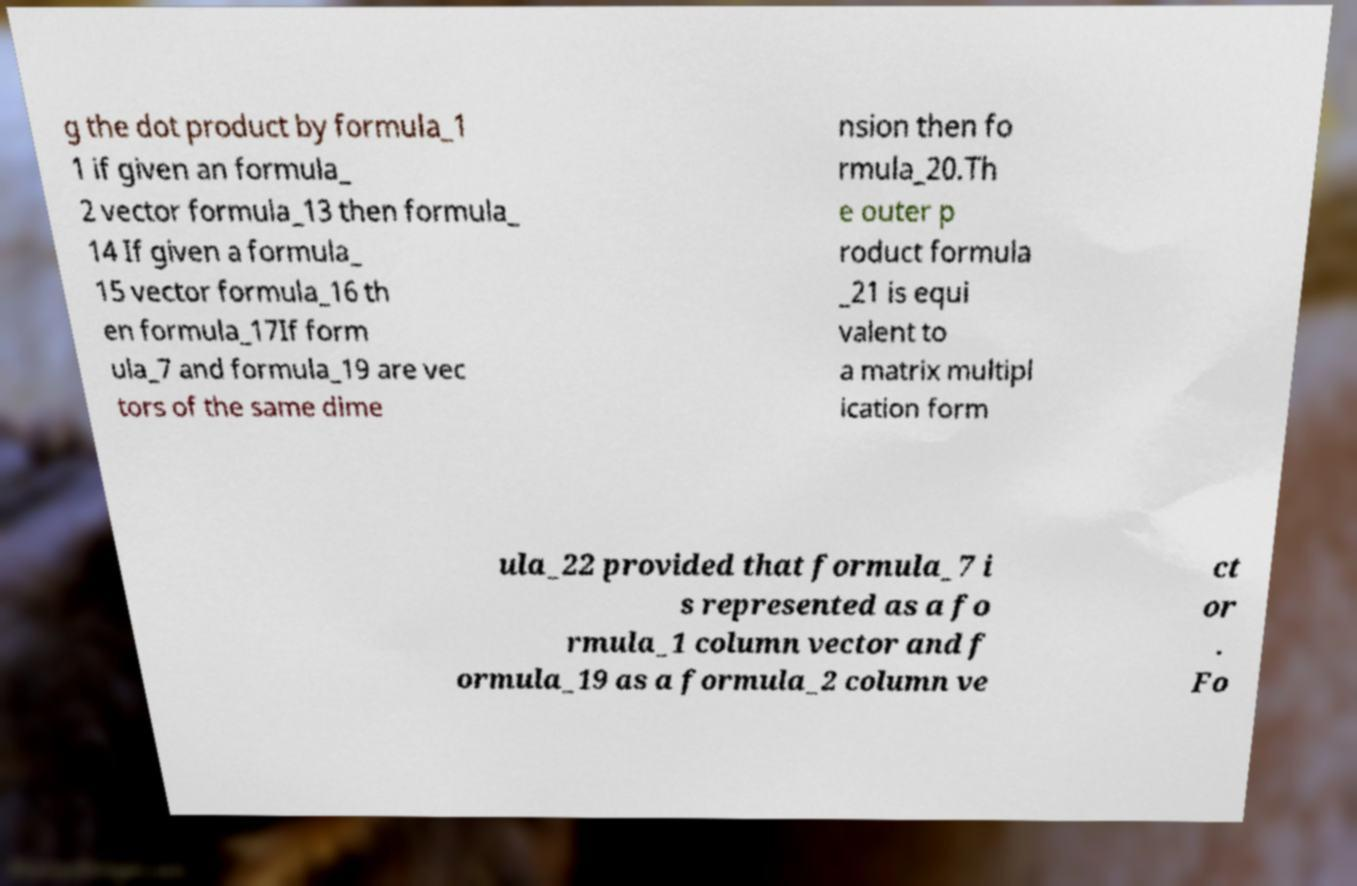Can you read and provide the text displayed in the image?This photo seems to have some interesting text. Can you extract and type it out for me? g the dot product by formula_1 1 if given an formula_ 2 vector formula_13 then formula_ 14 If given a formula_ 15 vector formula_16 th en formula_17If form ula_7 and formula_19 are vec tors of the same dime nsion then fo rmula_20.Th e outer p roduct formula _21 is equi valent to a matrix multipl ication form ula_22 provided that formula_7 i s represented as a fo rmula_1 column vector and f ormula_19 as a formula_2 column ve ct or . Fo 